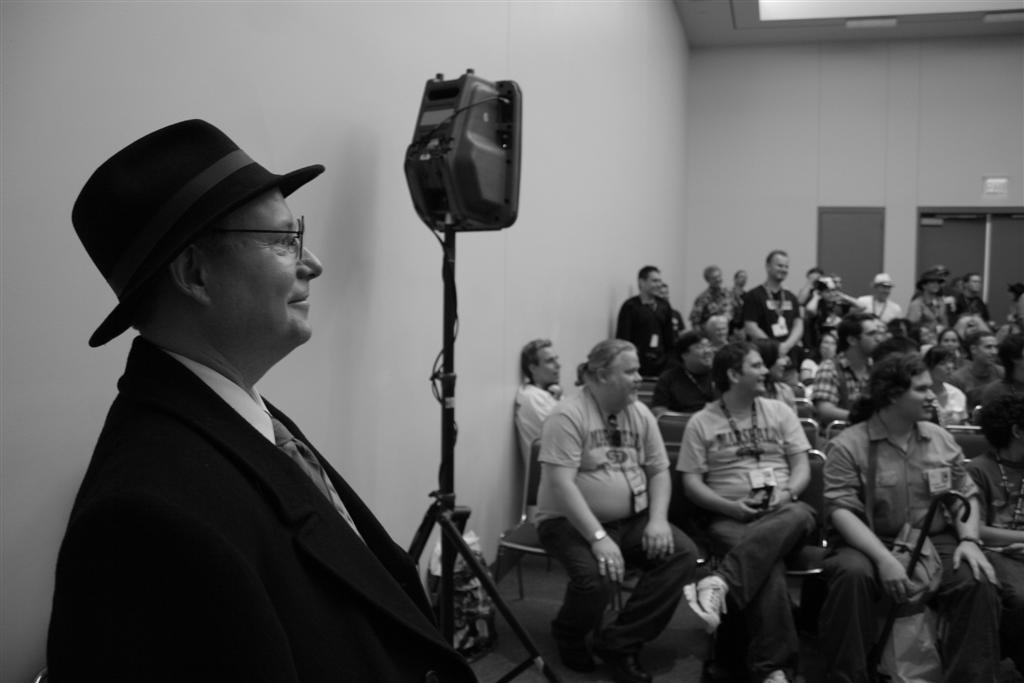What is located on the left side of the image? There is a man on the left side of the image. What is the man wearing in the image? The man is wearing a coat, shirt, tie, and hat. What can be seen on the right side of the image? There are people sitting on chairs on the right side of the image. What are the people doing in the image? The people are looking in the direction of the man. What is a feature of the background in the image? There is a wall in the image. What type of potato can be seen rolling on the floor in the image? There is no potato present in the image, and therefore no such activity can be observed. 